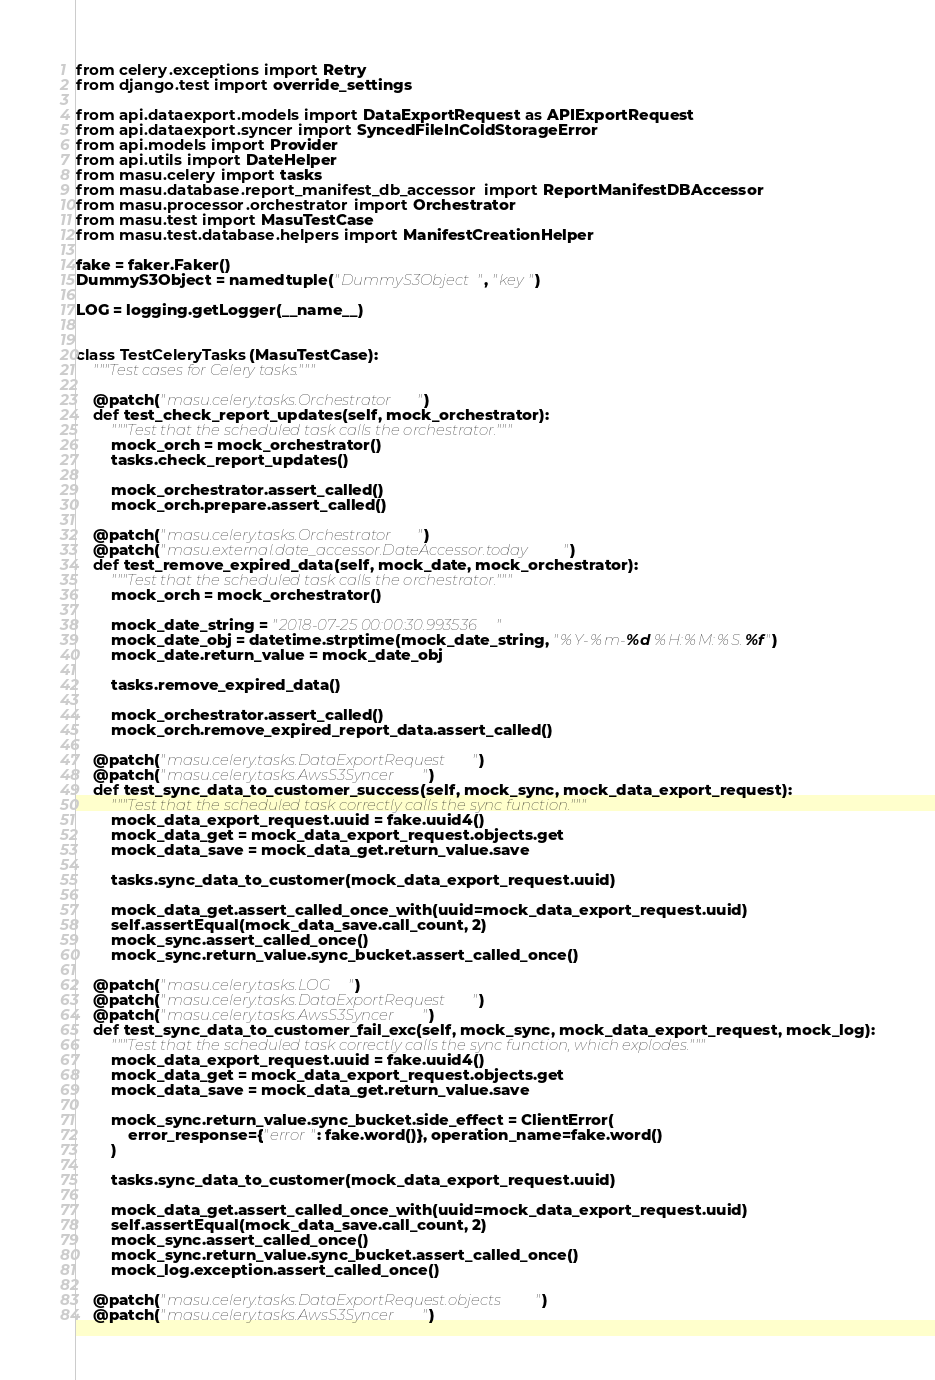Convert code to text. <code><loc_0><loc_0><loc_500><loc_500><_Python_>from celery.exceptions import Retry
from django.test import override_settings

from api.dataexport.models import DataExportRequest as APIExportRequest
from api.dataexport.syncer import SyncedFileInColdStorageError
from api.models import Provider
from api.utils import DateHelper
from masu.celery import tasks
from masu.database.report_manifest_db_accessor import ReportManifestDBAccessor
from masu.processor.orchestrator import Orchestrator
from masu.test import MasuTestCase
from masu.test.database.helpers import ManifestCreationHelper

fake = faker.Faker()
DummyS3Object = namedtuple("DummyS3Object", "key")

LOG = logging.getLogger(__name__)


class TestCeleryTasks(MasuTestCase):
    """Test cases for Celery tasks."""

    @patch("masu.celery.tasks.Orchestrator")
    def test_check_report_updates(self, mock_orchestrator):
        """Test that the scheduled task calls the orchestrator."""
        mock_orch = mock_orchestrator()
        tasks.check_report_updates()

        mock_orchestrator.assert_called()
        mock_orch.prepare.assert_called()

    @patch("masu.celery.tasks.Orchestrator")
    @patch("masu.external.date_accessor.DateAccessor.today")
    def test_remove_expired_data(self, mock_date, mock_orchestrator):
        """Test that the scheduled task calls the orchestrator."""
        mock_orch = mock_orchestrator()

        mock_date_string = "2018-07-25 00:00:30.993536"
        mock_date_obj = datetime.strptime(mock_date_string, "%Y-%m-%d %H:%M:%S.%f")
        mock_date.return_value = mock_date_obj

        tasks.remove_expired_data()

        mock_orchestrator.assert_called()
        mock_orch.remove_expired_report_data.assert_called()

    @patch("masu.celery.tasks.DataExportRequest")
    @patch("masu.celery.tasks.AwsS3Syncer")
    def test_sync_data_to_customer_success(self, mock_sync, mock_data_export_request):
        """Test that the scheduled task correctly calls the sync function."""
        mock_data_export_request.uuid = fake.uuid4()
        mock_data_get = mock_data_export_request.objects.get
        mock_data_save = mock_data_get.return_value.save

        tasks.sync_data_to_customer(mock_data_export_request.uuid)

        mock_data_get.assert_called_once_with(uuid=mock_data_export_request.uuid)
        self.assertEqual(mock_data_save.call_count, 2)
        mock_sync.assert_called_once()
        mock_sync.return_value.sync_bucket.assert_called_once()

    @patch("masu.celery.tasks.LOG")
    @patch("masu.celery.tasks.DataExportRequest")
    @patch("masu.celery.tasks.AwsS3Syncer")
    def test_sync_data_to_customer_fail_exc(self, mock_sync, mock_data_export_request, mock_log):
        """Test that the scheduled task correctly calls the sync function, which explodes."""
        mock_data_export_request.uuid = fake.uuid4()
        mock_data_get = mock_data_export_request.objects.get
        mock_data_save = mock_data_get.return_value.save

        mock_sync.return_value.sync_bucket.side_effect = ClientError(
            error_response={"error": fake.word()}, operation_name=fake.word()
        )

        tasks.sync_data_to_customer(mock_data_export_request.uuid)

        mock_data_get.assert_called_once_with(uuid=mock_data_export_request.uuid)
        self.assertEqual(mock_data_save.call_count, 2)
        mock_sync.assert_called_once()
        mock_sync.return_value.sync_bucket.assert_called_once()
        mock_log.exception.assert_called_once()

    @patch("masu.celery.tasks.DataExportRequest.objects")
    @patch("masu.celery.tasks.AwsS3Syncer")</code> 